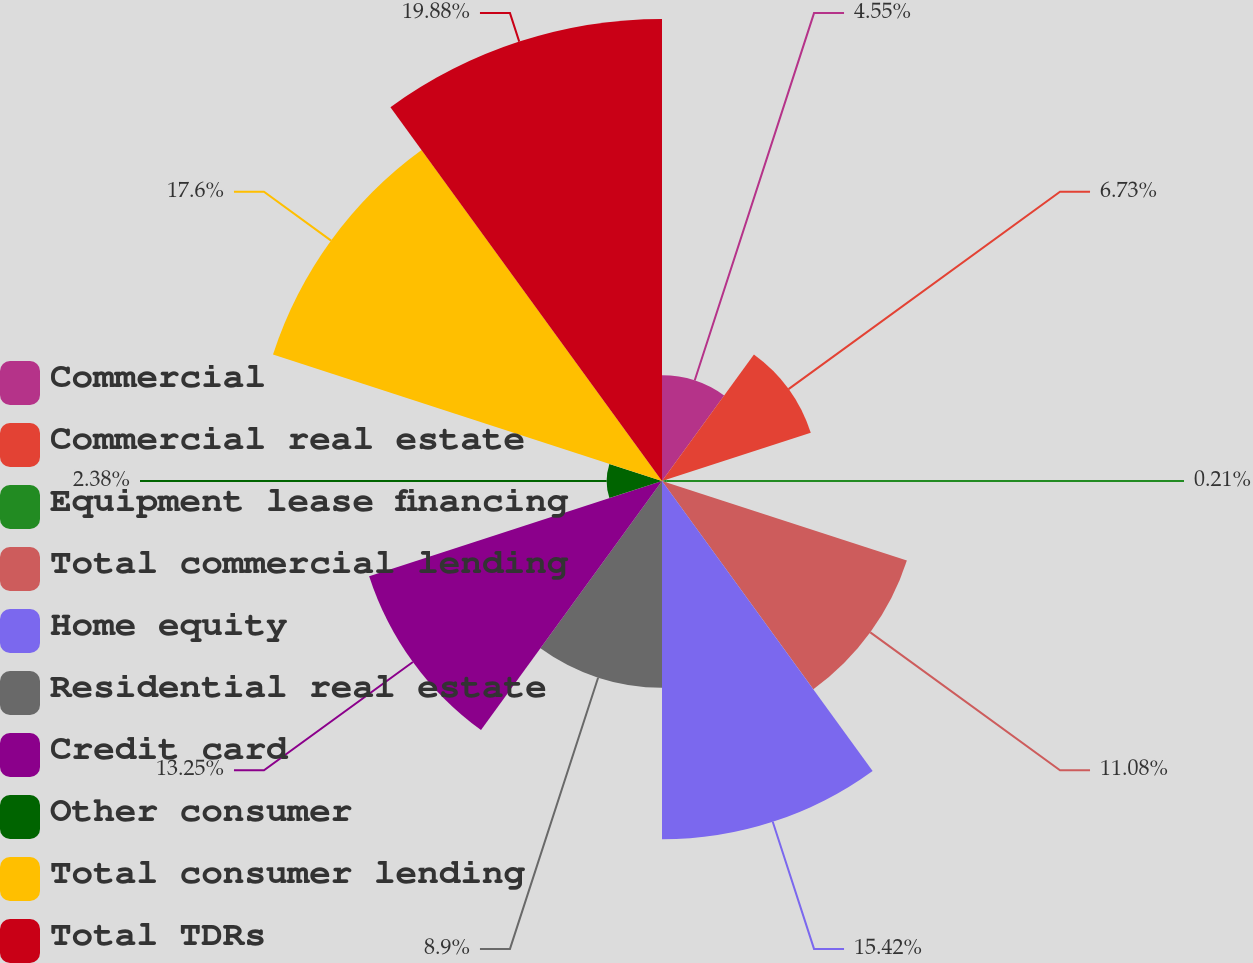Convert chart. <chart><loc_0><loc_0><loc_500><loc_500><pie_chart><fcel>Commercial<fcel>Commercial real estate<fcel>Equipment lease financing<fcel>Total commercial lending<fcel>Home equity<fcel>Residential real estate<fcel>Credit card<fcel>Other consumer<fcel>Total consumer lending<fcel>Total TDRs<nl><fcel>4.55%<fcel>6.73%<fcel>0.21%<fcel>11.08%<fcel>15.42%<fcel>8.9%<fcel>13.25%<fcel>2.38%<fcel>17.6%<fcel>19.88%<nl></chart> 